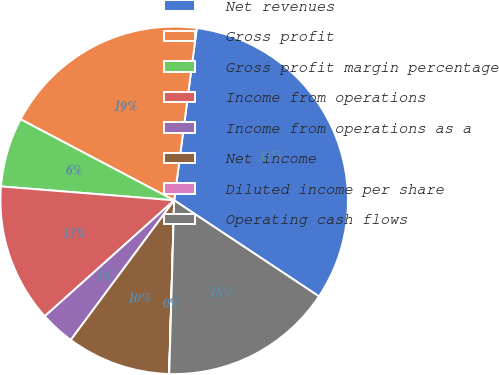Convert chart to OTSL. <chart><loc_0><loc_0><loc_500><loc_500><pie_chart><fcel>Net revenues<fcel>Gross profit<fcel>Gross profit margin percentage<fcel>Income from operations<fcel>Income from operations as a<fcel>Net income<fcel>Diluted income per share<fcel>Operating cash flows<nl><fcel>32.25%<fcel>19.35%<fcel>6.45%<fcel>12.9%<fcel>3.23%<fcel>9.68%<fcel>0.01%<fcel>16.13%<nl></chart> 